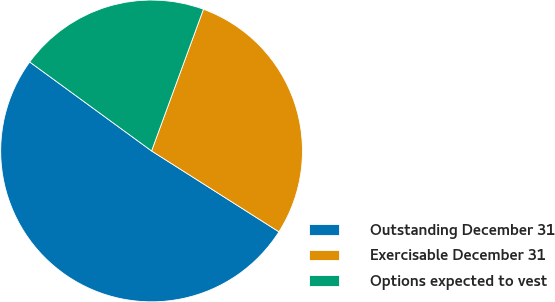Convert chart to OTSL. <chart><loc_0><loc_0><loc_500><loc_500><pie_chart><fcel>Outstanding December 31<fcel>Exercisable December 31<fcel>Options expected to vest<nl><fcel>51.03%<fcel>28.42%<fcel>20.55%<nl></chart> 